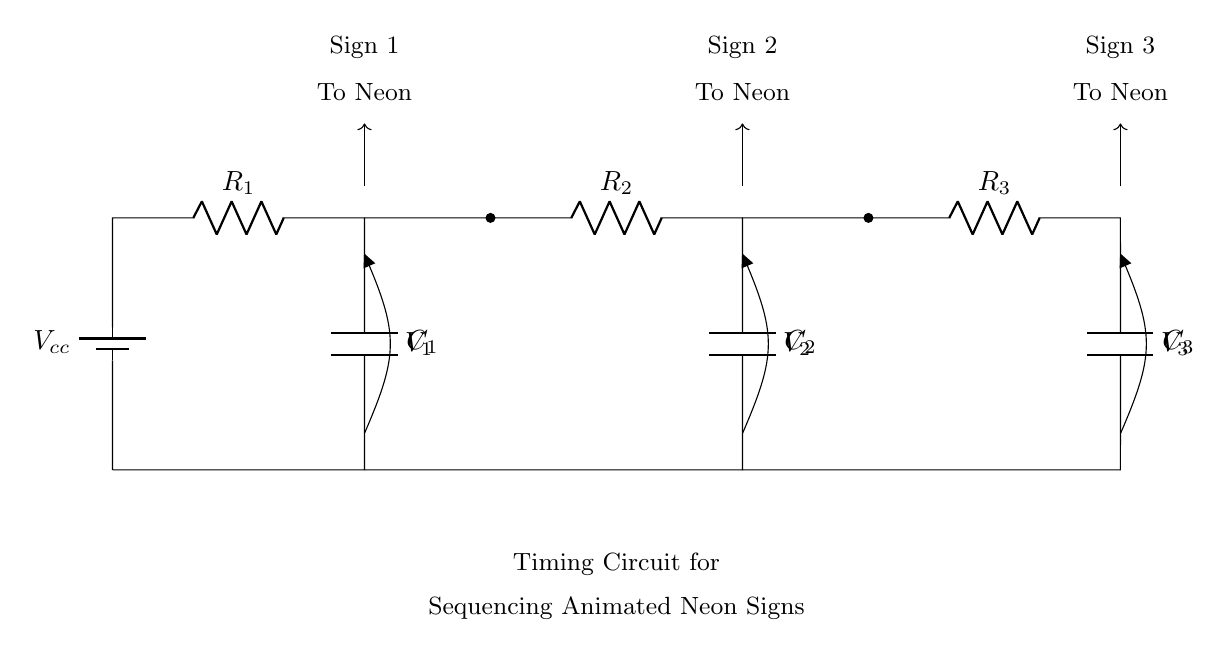What are the components used in this circuit? The circuit contains resistors R1, R2, R3 and capacitors C1, C2, C3, and a battery providing voltage Vcc.
Answer: R1, R2, R3, C1, C2, C3, Vcc What is the function of this timing circuit? The timing circuit is designed to sequence animated neon signs in storefronts by controlling the timing of their illumination based on the charge and discharge of capacitors.
Answer: Sequencing neon signs What is the voltage source in this circuit? The voltage source is labeled as Vcc, which provides the necessary energy for the circuit operation.
Answer: Vcc How many timing stages are present in this circuit? There are three timing stages in the circuit, indicated by the presence of three pairs of resistor-capacitor circuits.
Answer: Three What is the role of capacitors in this timing circuit? The capacitors store and release electrical energy, which helps regulate the timing of the voltage levels for the sequential illumination of the neon signs.
Answer: Timing regulation What would happen if R2 were to be removed? If R2 is removed, the timing circuit would be disrupted as there would be an incomplete pathway for current flow, affecting the charging and discharging cycles of the capacitors.
Answer: Disruption of timing Which neon sign is triggered first in the sequence? The timing circuit suggests that the neon sign connected to the first timing stage (R1 and C1) will be activated first due to its direct connection to Vcc.
Answer: Neon sign 1 